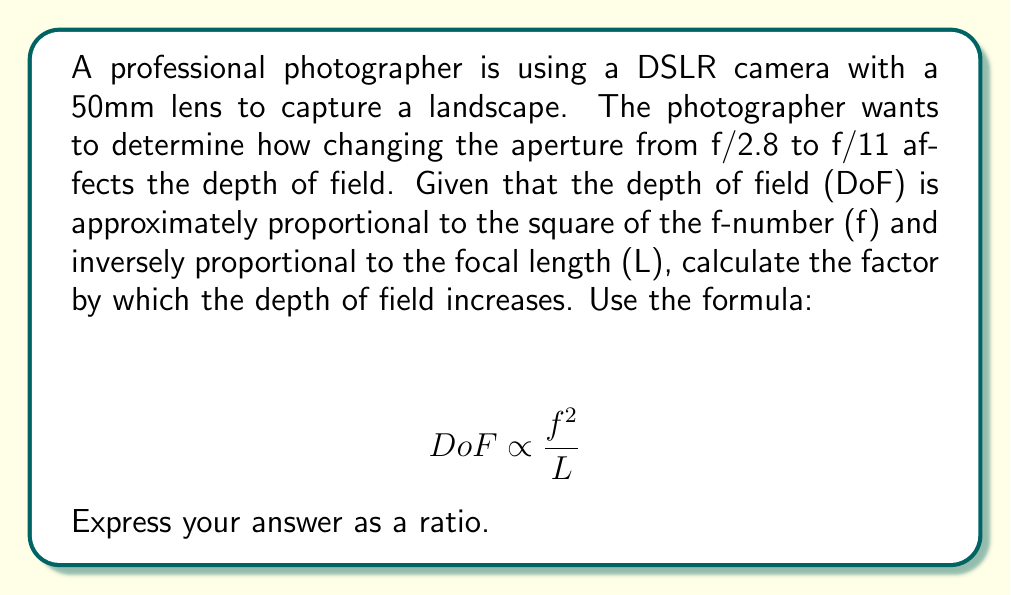Could you help me with this problem? Let's approach this step-by-step:

1) We are given that $DoF \propto \frac{f^2}{L}$, where $f$ is the f-number and $L$ is the focal length.

2) The focal length (L) remains constant at 50mm, so we can focus on how $f^2$ changes.

3) Initial aperture: f/2.8
   Final aperture: f/11

4) Let's call the initial depth of field $DoF_1$ and the final depth of field $DoF_2$.

5) The ratio of the depth of fields will be:

   $$ \frac{DoF_2}{DoF_1} = \frac{11^2}{2.8^2} $$

6) Let's calculate this:
   $$ \frac{DoF_2}{DoF_1} = \frac{121}{7.84} \approx 15.43 $$

7) This means the depth of field at f/11 is approximately 15.43 times larger than at f/2.8.

8) We can express this as a ratio: 15.43:1
Answer: 15.43:1 